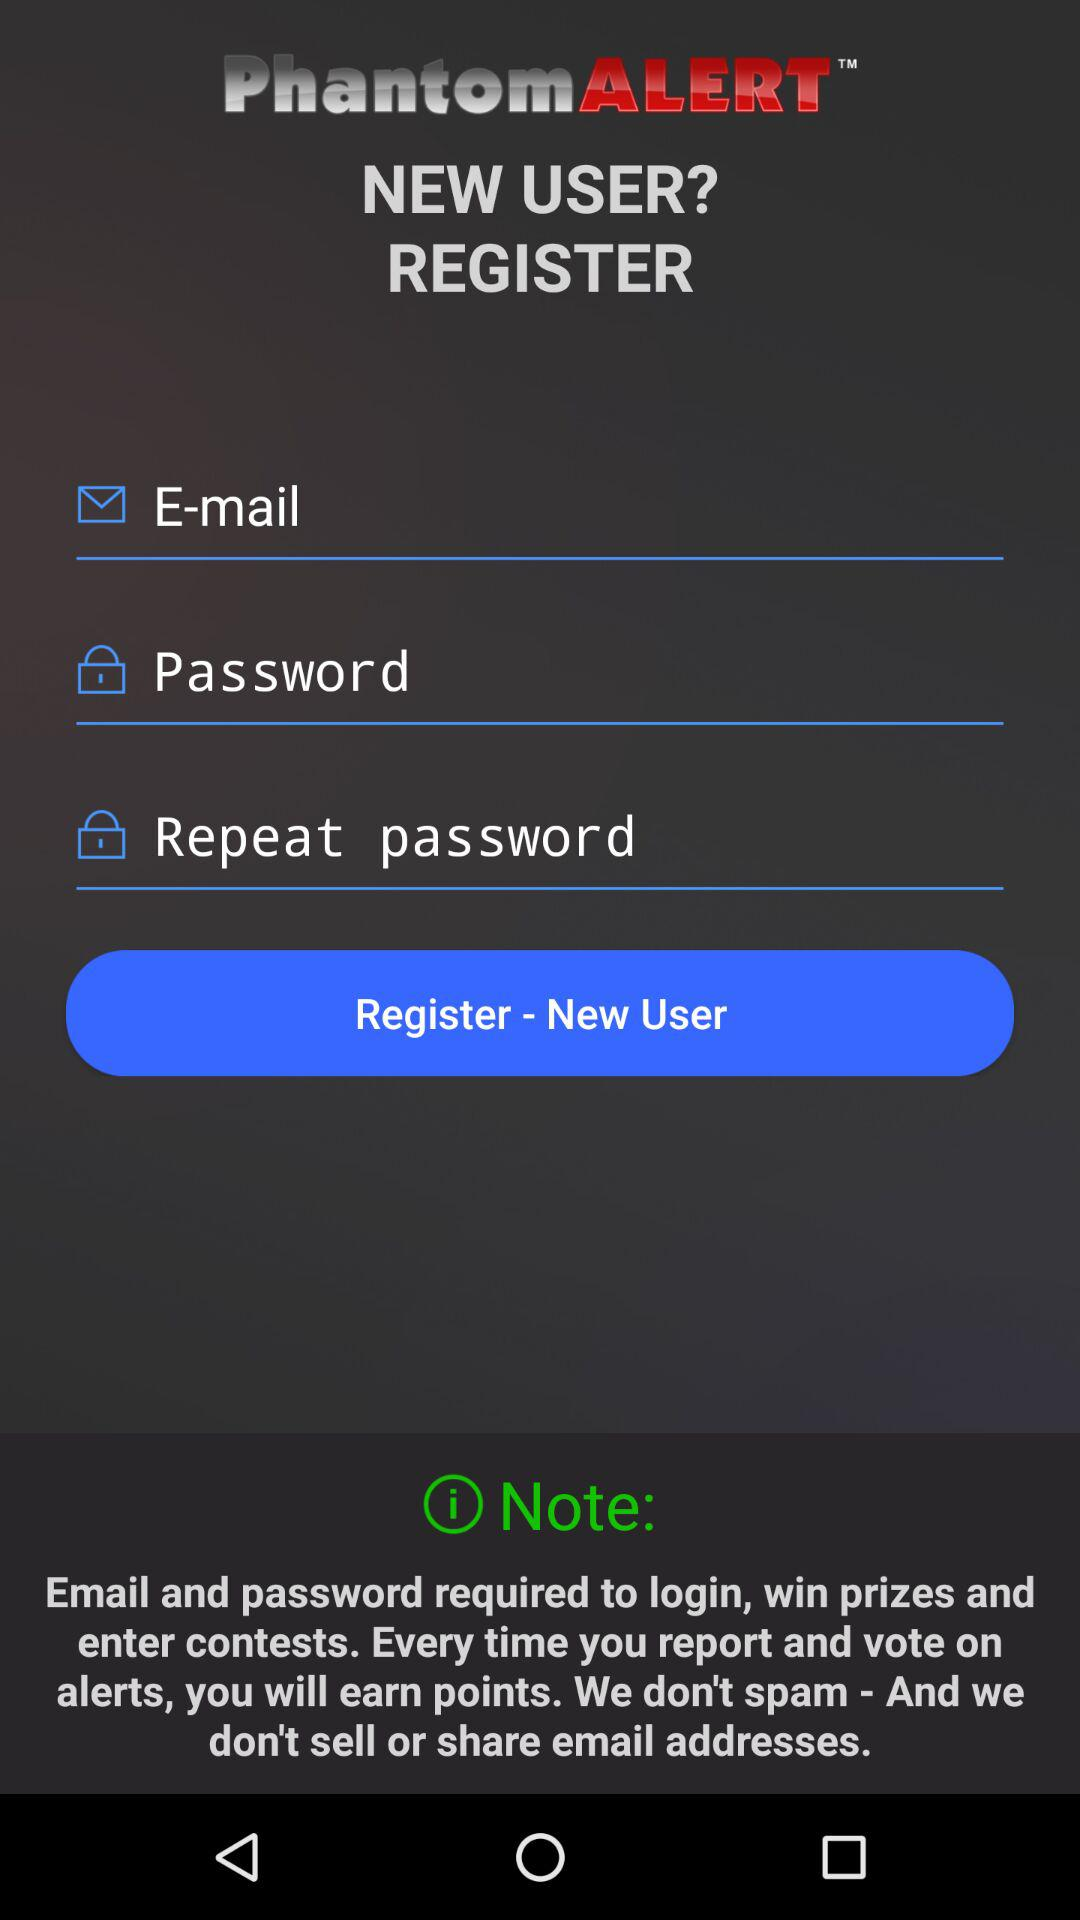How many text inputs are in the registration form?
Answer the question using a single word or phrase. 3 